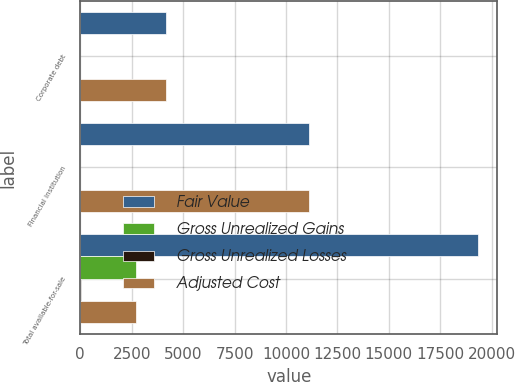Convert chart. <chart><loc_0><loc_0><loc_500><loc_500><stacked_bar_chart><ecel><fcel>Corporate debt<fcel>Financial institution<fcel>Total available-for-sale<nl><fcel>Fair Value<fcel>4164<fcel>11140<fcel>19311<nl><fcel>Gross Unrealized Gains<fcel>3<fcel>1<fcel>2710<nl><fcel>Gross Unrealized Losses<fcel>10<fcel>2<fcel>14<nl><fcel>Adjusted Cost<fcel>4157<fcel>11139<fcel>2710<nl></chart> 